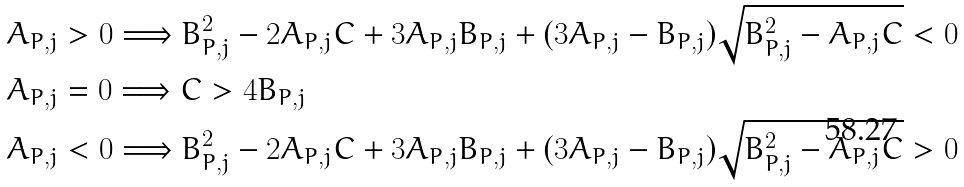Convert formula to latex. <formula><loc_0><loc_0><loc_500><loc_500>& A _ { P , j } > 0 \Longrightarrow B _ { P , j } ^ { 2 } - 2 A _ { P , j } C + 3 A _ { P , j } B _ { P , j } + ( 3 A _ { P , j } - B _ { P , j } ) \sqrt { B _ { P , j } ^ { 2 } - A _ { P , j } C } < 0 \\ & A _ { P , j } = 0 \Longrightarrow C > 4 B _ { P , j } \\ & A _ { P , j } < 0 \Longrightarrow B _ { P , j } ^ { 2 } - 2 A _ { P , j } C + 3 A _ { P , j } B _ { P , j } + ( 3 A _ { P , j } - B _ { P , j } ) \sqrt { B _ { P , j } ^ { 2 } - A _ { P , j } C } > 0</formula> 